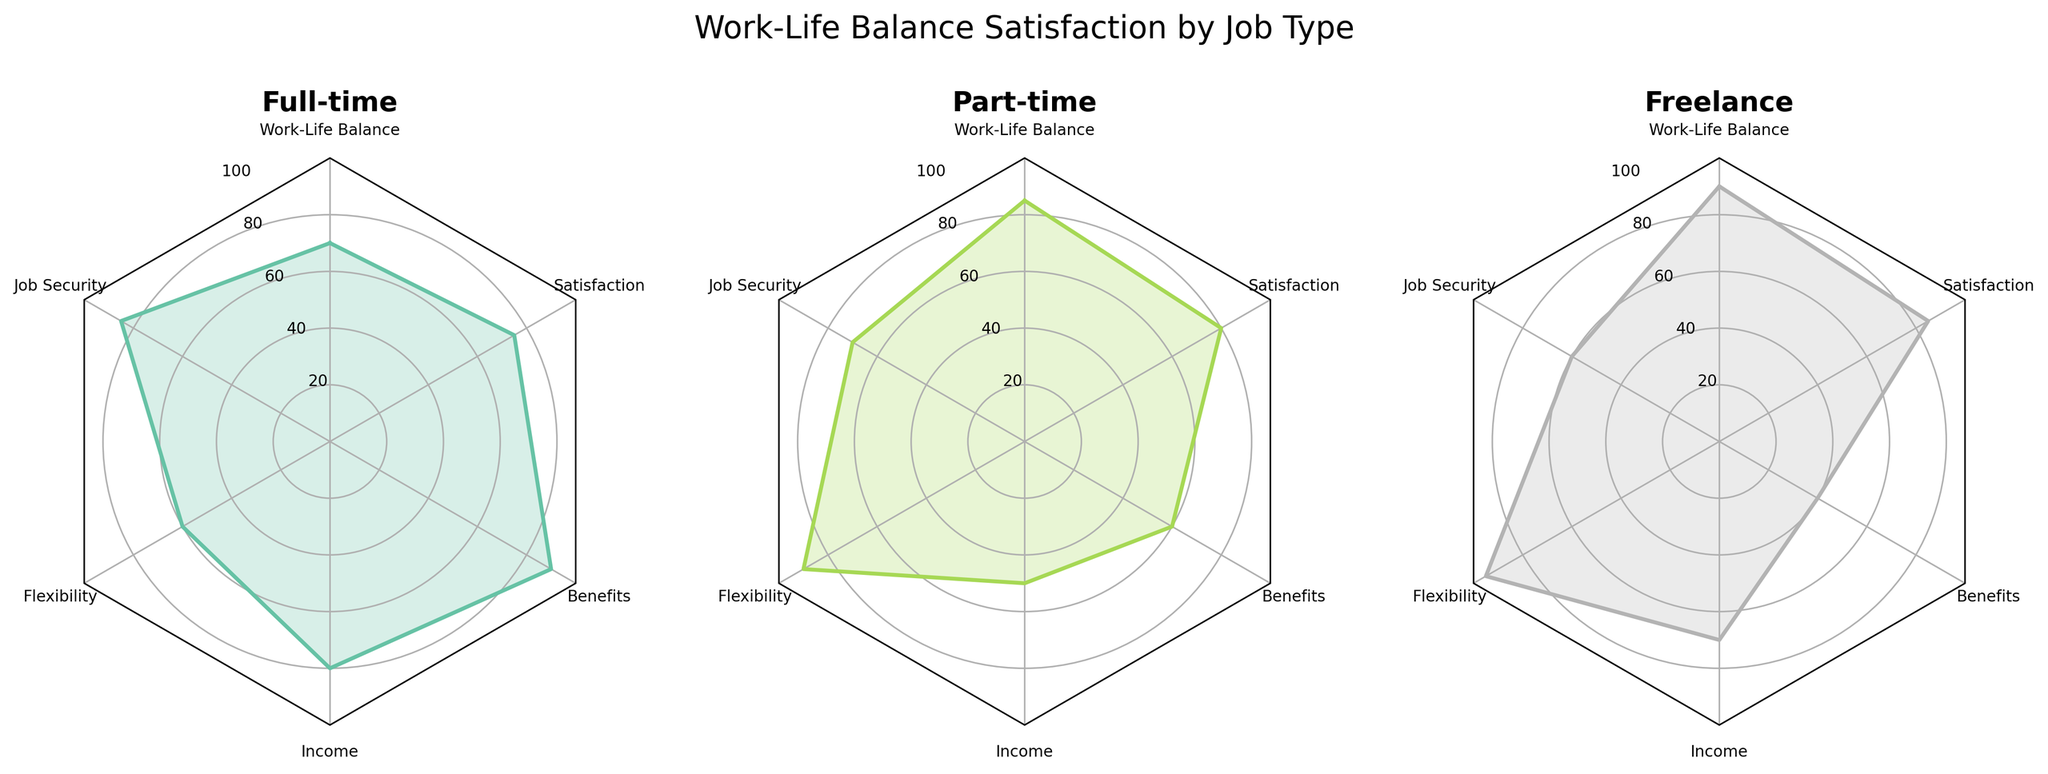Which job type has the highest value for flexibility? The Freelance job type has the highest value for flexibility, as indicated by its point being farthest from the center in the 'Flexibility' dimension on its radar chart.
Answer: Freelance Which job type scores the lowest on Benefits? On the Freelance radar chart, the Benefits dimension point is closest to the center, indicating the lowest score.
Answer: Freelance How does Full-time compare to Part-time in terms of Job Security? On the radar charts, the point for Job Security is farther from the center for Full-time than for Part-time, indicating a higher score for Full-time.
Answer: Full-time What's the average value of Satisfaction across all job types? Satisfaction values for each job type: Full-time (75+80+77)/3 = 77.33, Part-time (80+75+78)/3 = 77.67, Freelance (85+83+86)/3 = 84.67. The overall average is (77.33 + 77.67 + 84.67)/3.
Answer: 79.89 Which job type has the most consistent (least variation) values across all categories? Comparing the radar charts, Part-time job type values appear to have the least variation, with its points on the chart being more evenly spaced across dimensions.
Answer: Part-time Is there any category in which all job types score above 60? By comparing all radar charts, each job type scores above 60 in Work-Life Balance, Flexibility, and Satisfaction dimensions.
Answer: Yes, in Work-Life Balance, Flexibility, and Satisfaction Which job type has the lowest score in Income? Part-time job type radar chart shows the nearest point to the center in the Income dimension.
Answer: Part-time Between Full-time and Freelance, which job type has higher overall scores on average? Calculate the average score for each dimension and then overall: Full-time: (70+85+60+80+90+75)/6 = 76.67, (75+80+65+85+85+80)/6 = 78.33, (78+82+68+78+88+77)/6 = 78.83. Freelance: (90+60+95+70+40+85)/6 = 73.33, (88+65+93+75+45+83)/6 = 74.83, (91+63+94+72+42+86)/6 = 74.67. Full-time has higher overall.
Answer: Full-time 